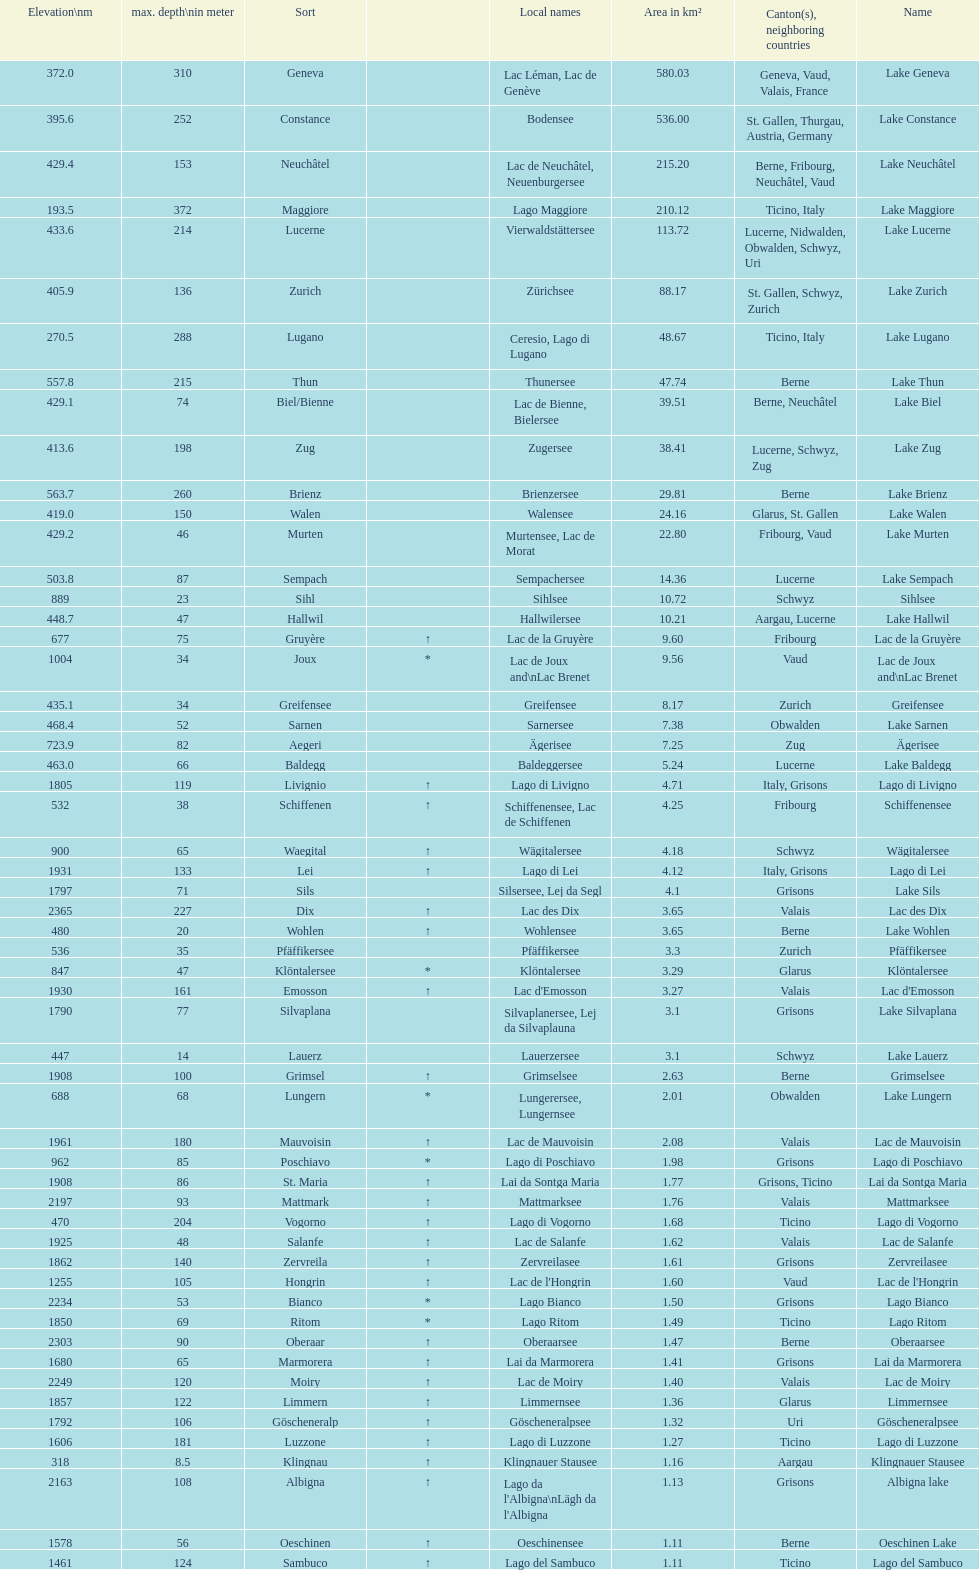What's the total max depth of lake geneva and lake constance combined? 562. 